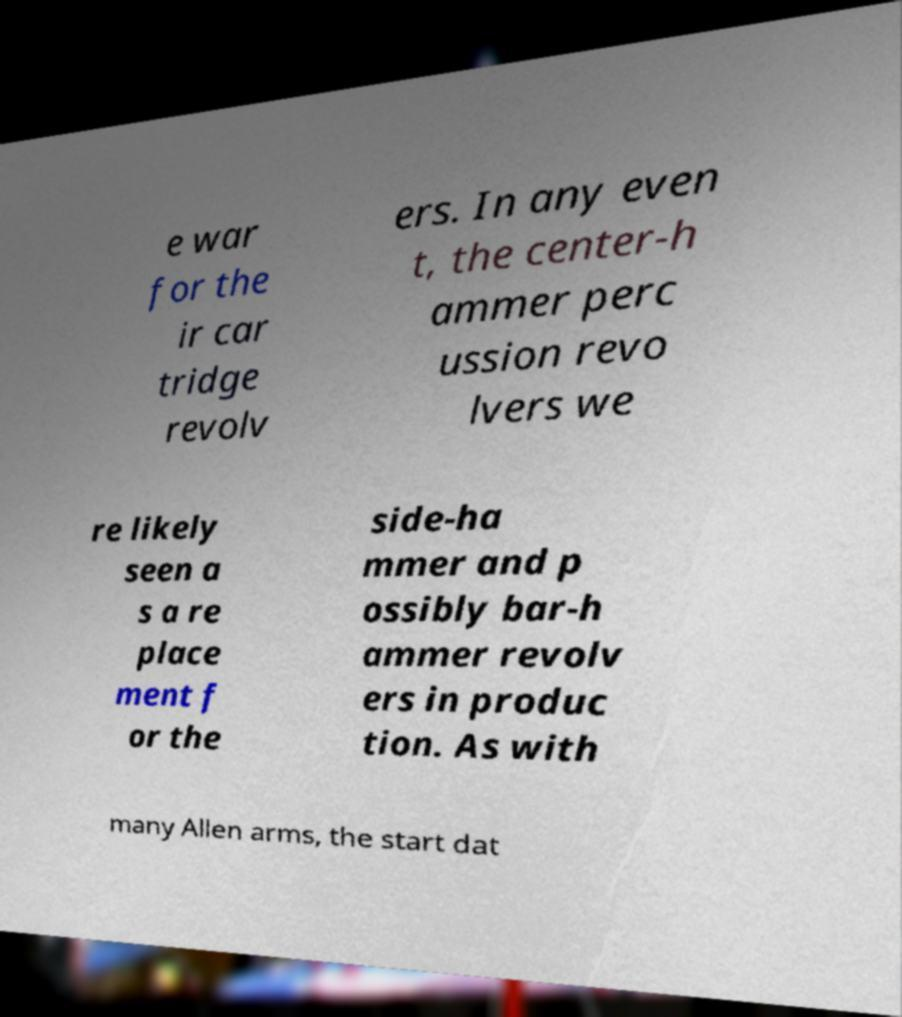Please identify and transcribe the text found in this image. e war for the ir car tridge revolv ers. In any even t, the center-h ammer perc ussion revo lvers we re likely seen a s a re place ment f or the side-ha mmer and p ossibly bar-h ammer revolv ers in produc tion. As with many Allen arms, the start dat 